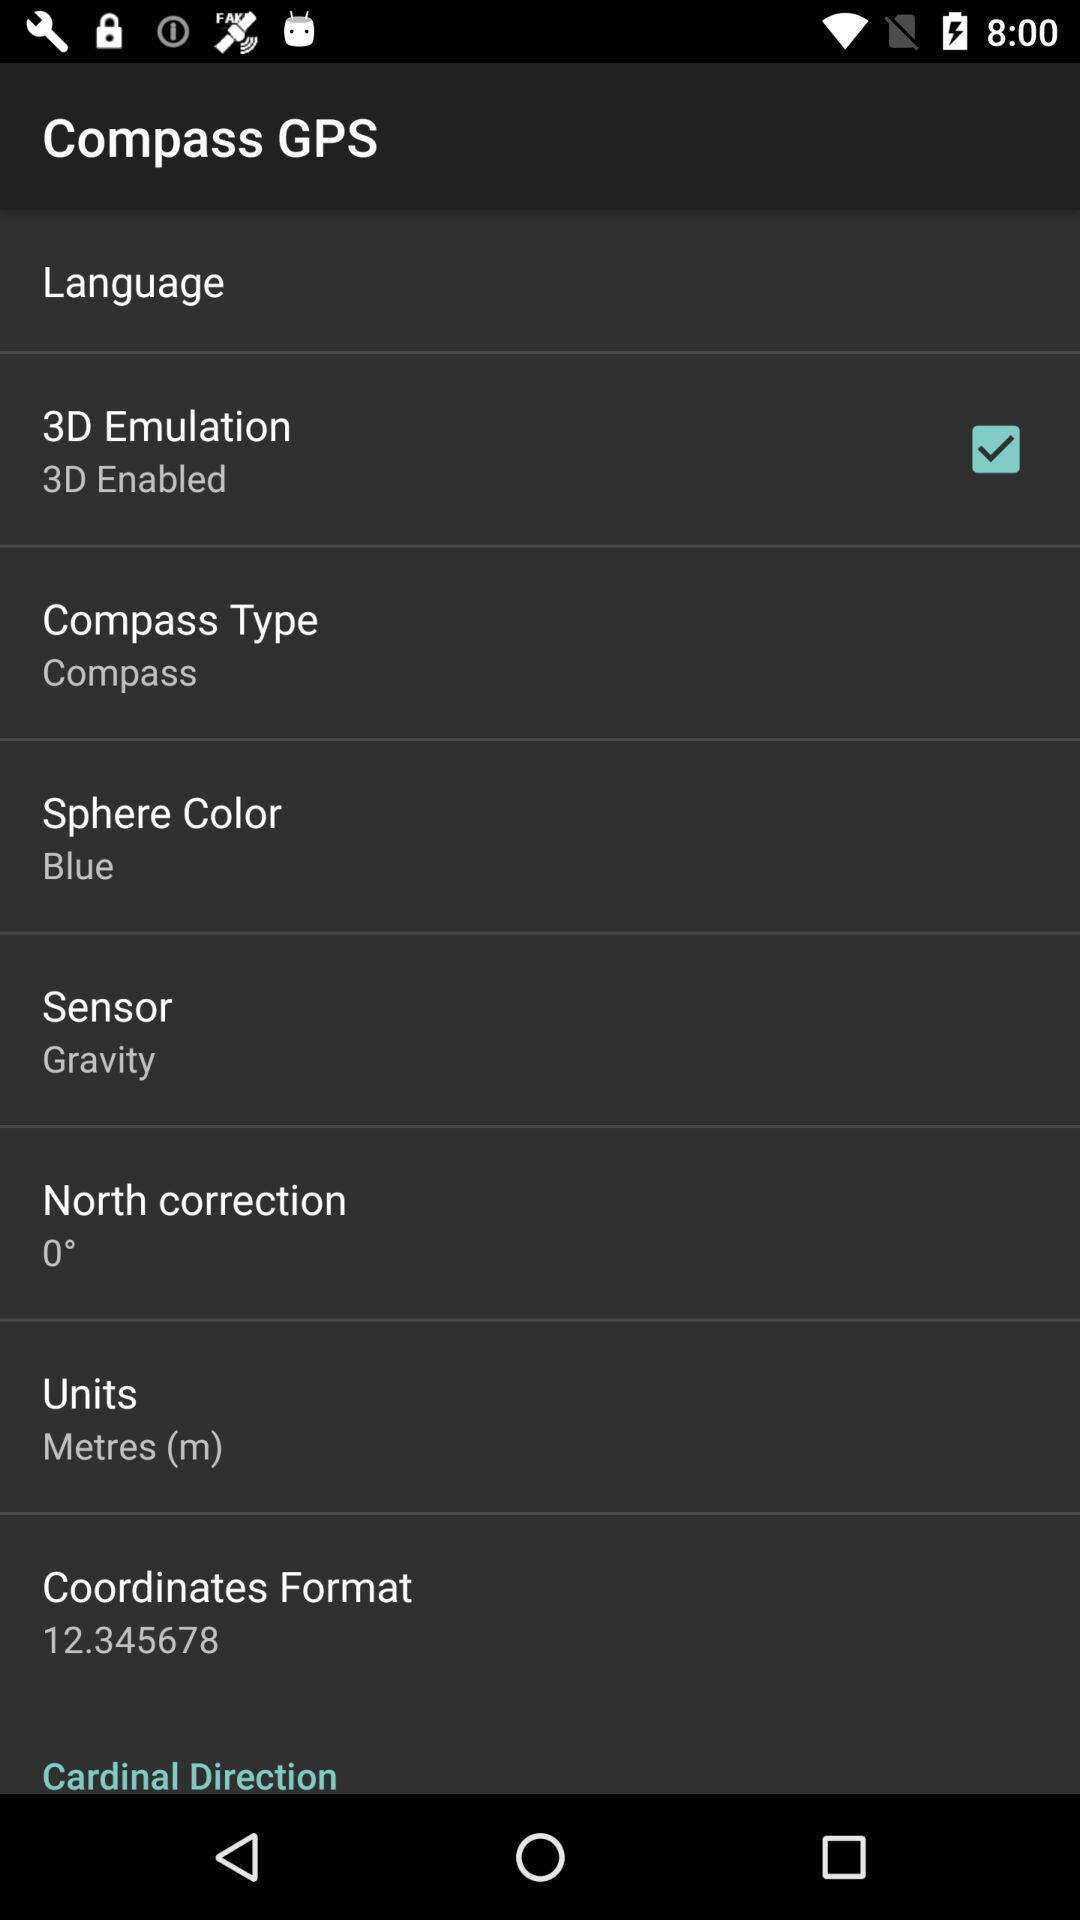What is the value of the magnetic field? The value of the magnetic field is 73.17 μT. 